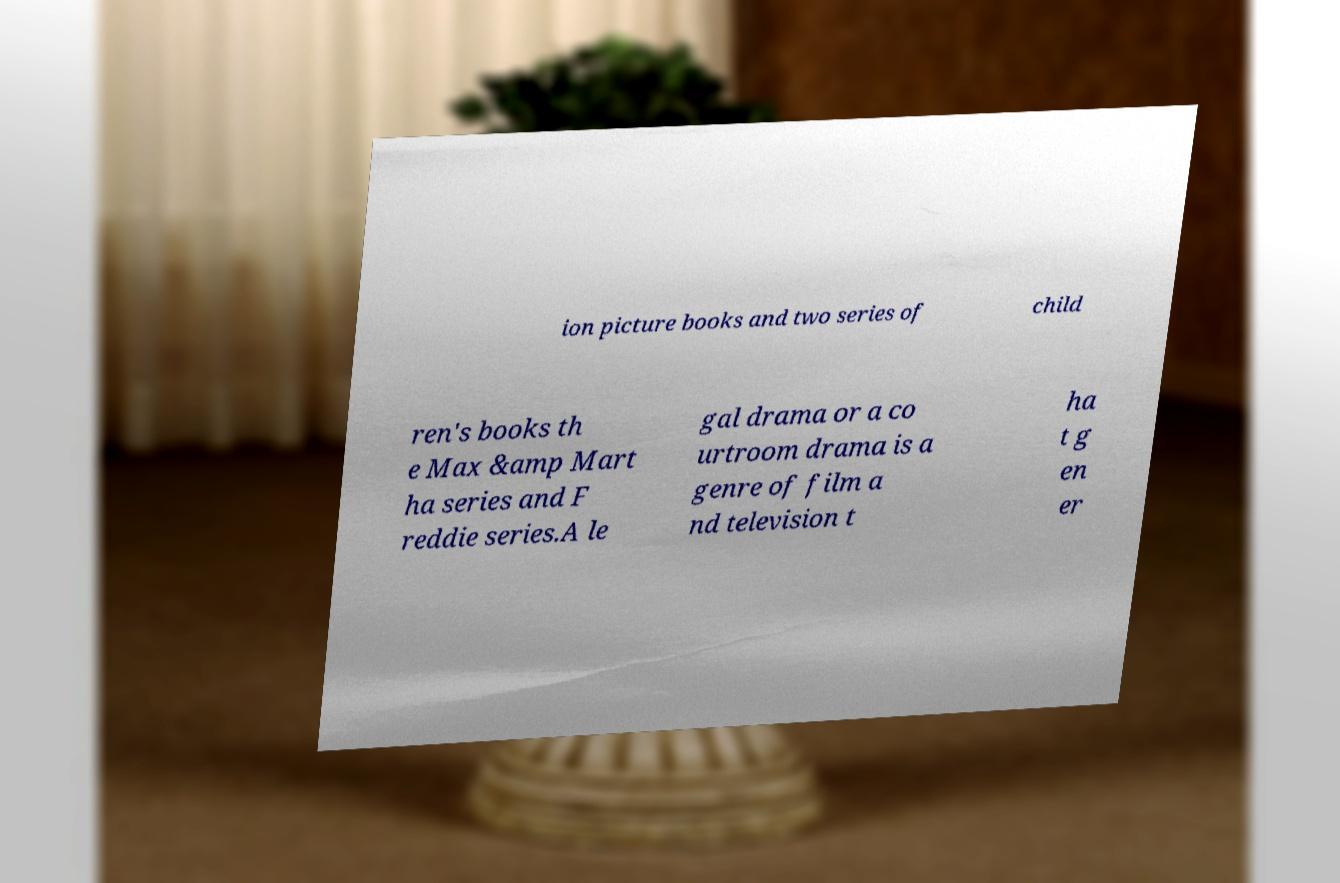Could you extract and type out the text from this image? ion picture books and two series of child ren's books th e Max &amp Mart ha series and F reddie series.A le gal drama or a co urtroom drama is a genre of film a nd television t ha t g en er 